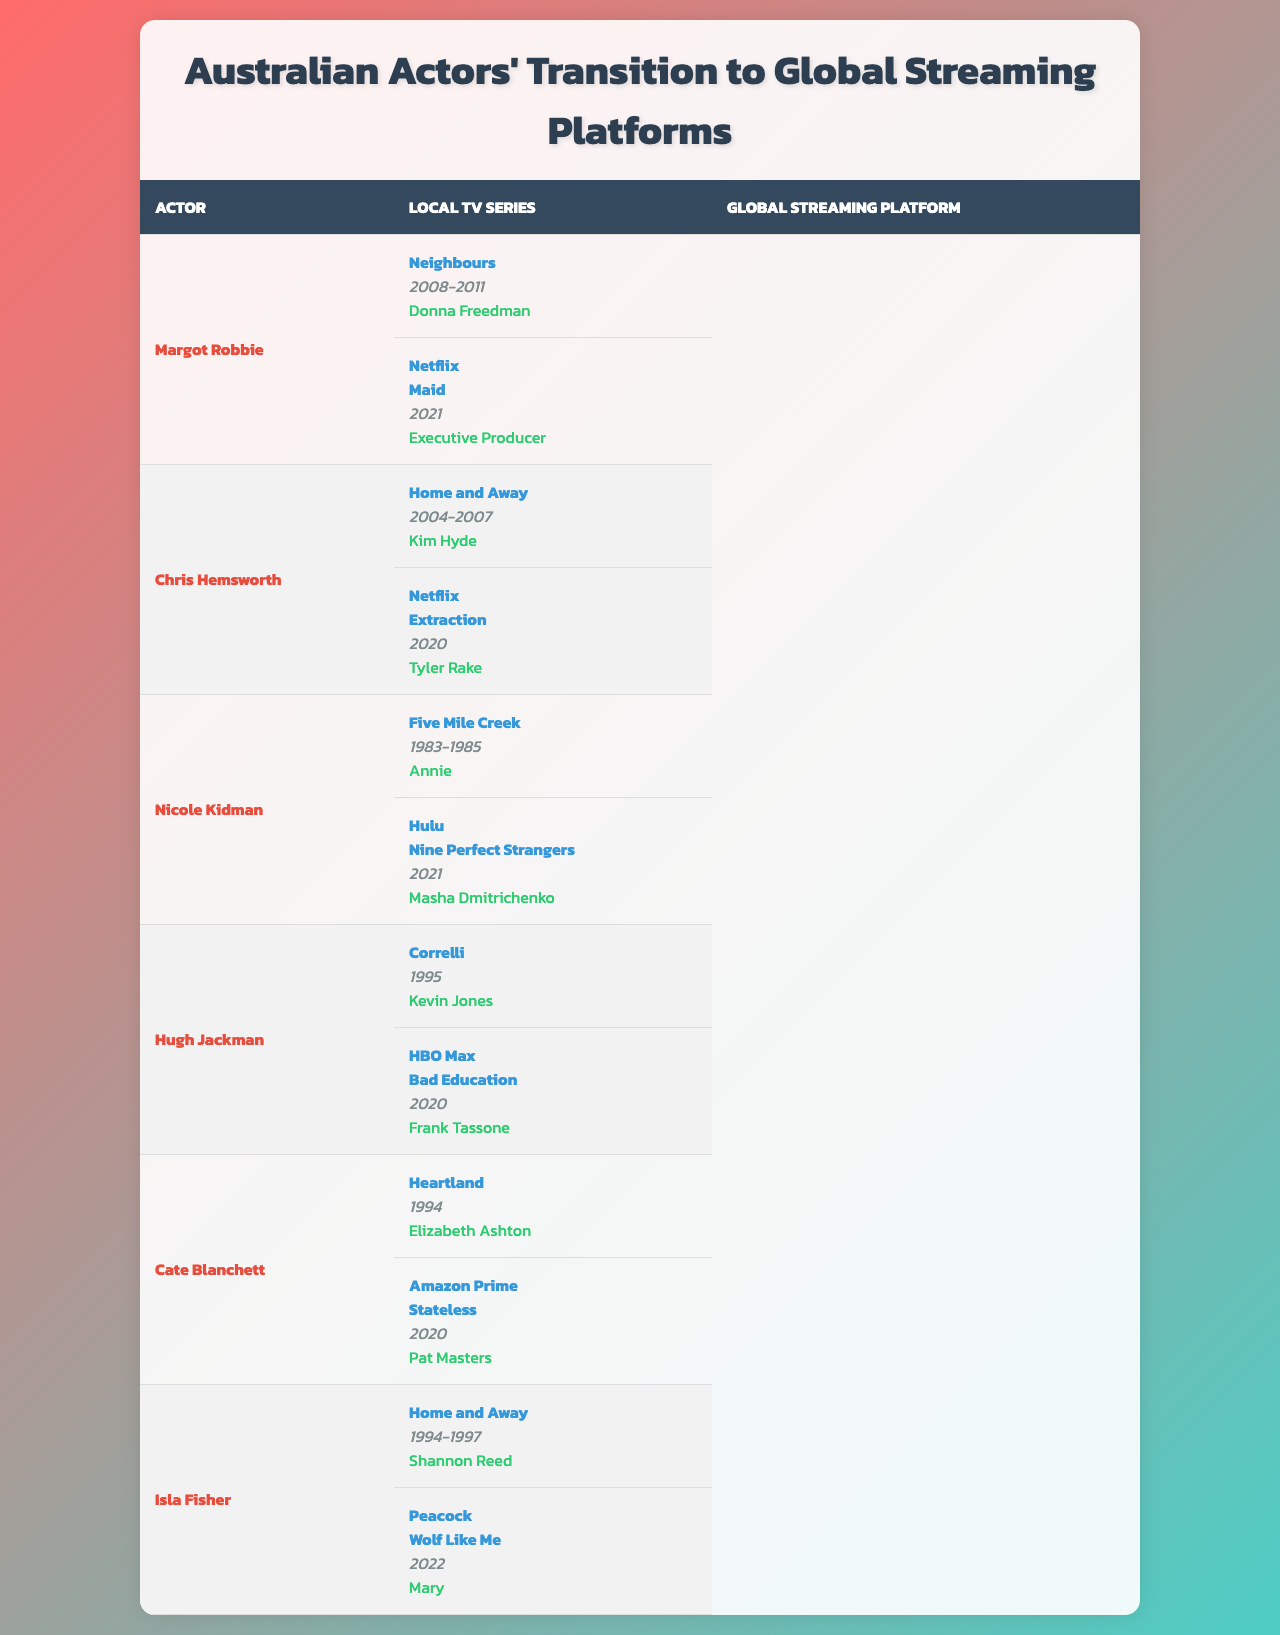What local TV series did Margot Robbie star in? The table lists Margot Robbie's local TV series as "Neighbours."
Answer: Neighbours In what year did Chris Hemsworth begin his role in "Home and Away"? The table shows that Chris Hemsworth was in "Home and Away" from 2004 to 2007, indicating he began in 2004.
Answer: 2004 Which actor has worked as an executive producer on a Netflix project? The data specifies that Margot Robbie served as an executive producer on the Netflix project "Maid."
Answer: Margot Robbie Did Nicole Kidman transition to a streaming platform in 2021? The table indicates that Nicole Kidman starred in "Nine Perfect Strangers" on Hulu in 2021, confirming the transition.
Answer: Yes How many actors from the table starred in "Home and Away"? The data reveals that both Chris Hemsworth and Isla Fisher starred in "Home and Away," totaling two actors.
Answer: 2 What is the role of Hugh Jackman in the project listed under HBO Max? According to the table, Hugh Jackman's role in "Bad Education" is "Frank Tassone."
Answer: Frank Tassone Which actor transitioned from local TV to a Hulu project? The table indicates that Nicole Kidman transitioned from "Five Mile Creek" to "Nine Perfect Strangers" on Hulu.
Answer: Nicole Kidman How many years did Cate Blanchett appear in her local TV series? The years listed for Cate Blanchett in "Heartland" are 1994, indicating her appearance in that year. Since there's only one year listed, she appeared for one year.
Answer: 1 What commonality do Chris Hemsworth and Isla Fisher share regarding their local TV series? Both actors starred in "Home and Away," indicating a commonality in their local TV experience.
Answer: "Home and Away" Which platform featured the project "Wolf Like Me"? The data specifies that "Wolf Like Me" is available on Peacock, thus that is the platform featuring it.
Answer: Peacock Which actor shifted from a local TV role to a leading role in a Netflix film shortly before 2021? Chris Hemsworth transitioned from his role in "Home and Away" to a leading role in the Netflix film "Extraction" in 2020, which is shortly before 2021.
Answer: Chris Hemsworth 